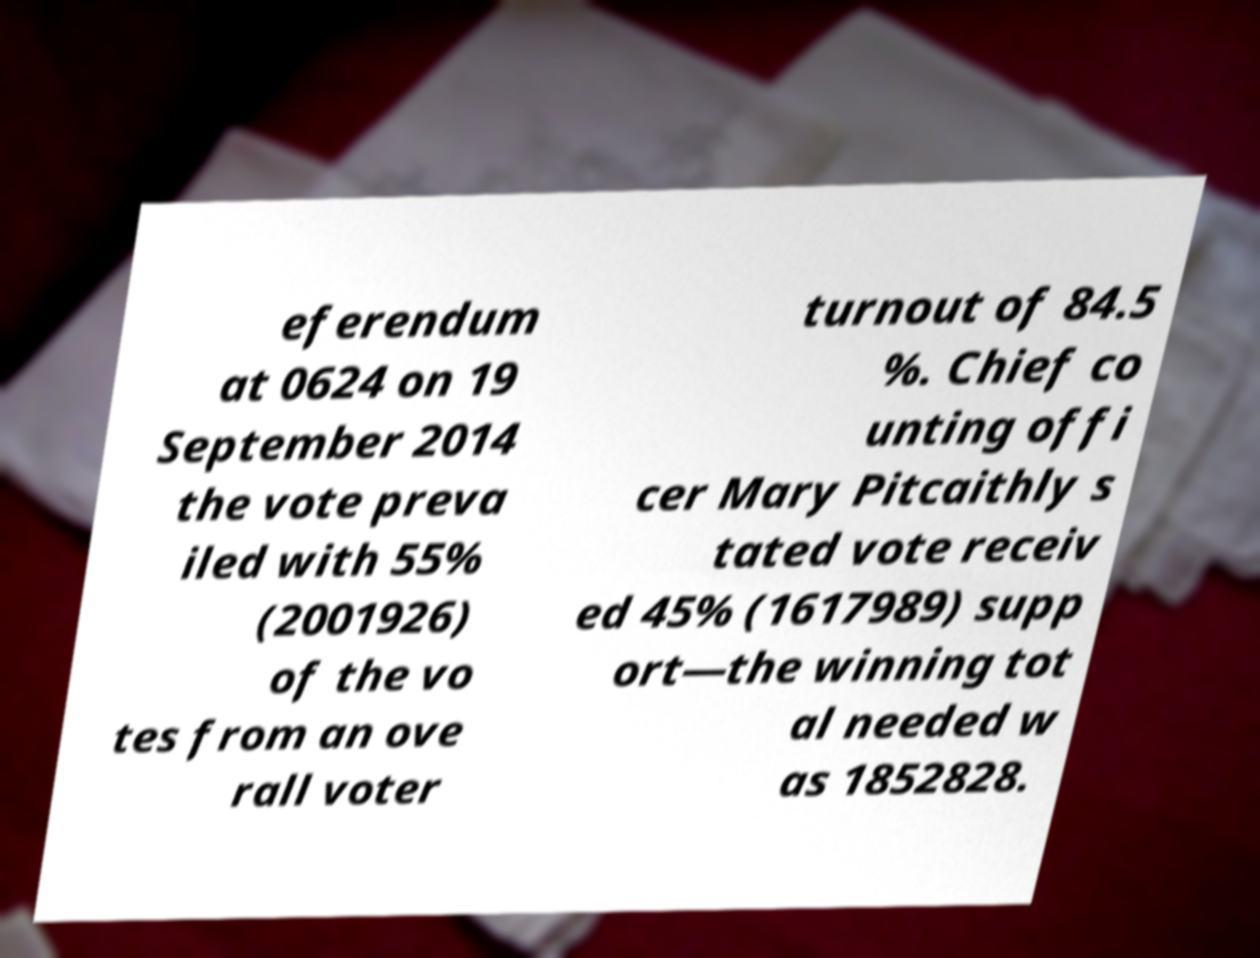Please read and relay the text visible in this image. What does it say? eferendum at 0624 on 19 September 2014 the vote preva iled with 55% (2001926) of the vo tes from an ove rall voter turnout of 84.5 %. Chief co unting offi cer Mary Pitcaithly s tated vote receiv ed 45% (1617989) supp ort—the winning tot al needed w as 1852828. 